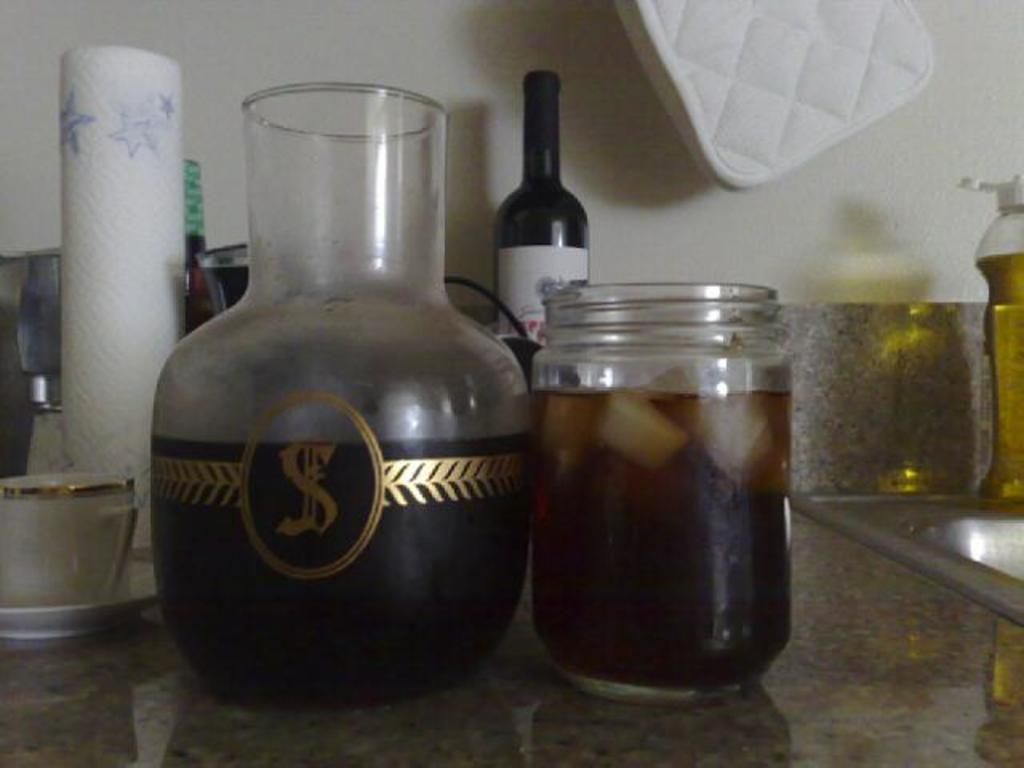What type of glass is present in the image? There is a funnel glass and a jar of glass in the image. What is inside the jar? The jar contains juice and ice cubes. Can you describe the contents of the funnel glass? The facts provided do not specify the contents of the funnel glass. What is located at the back of the image? There is a tissue roll at the back of the image. What month is depicted on the shoe in the image? There is no shoe present in the image, so it is not possible to determine the month depicted on it. 